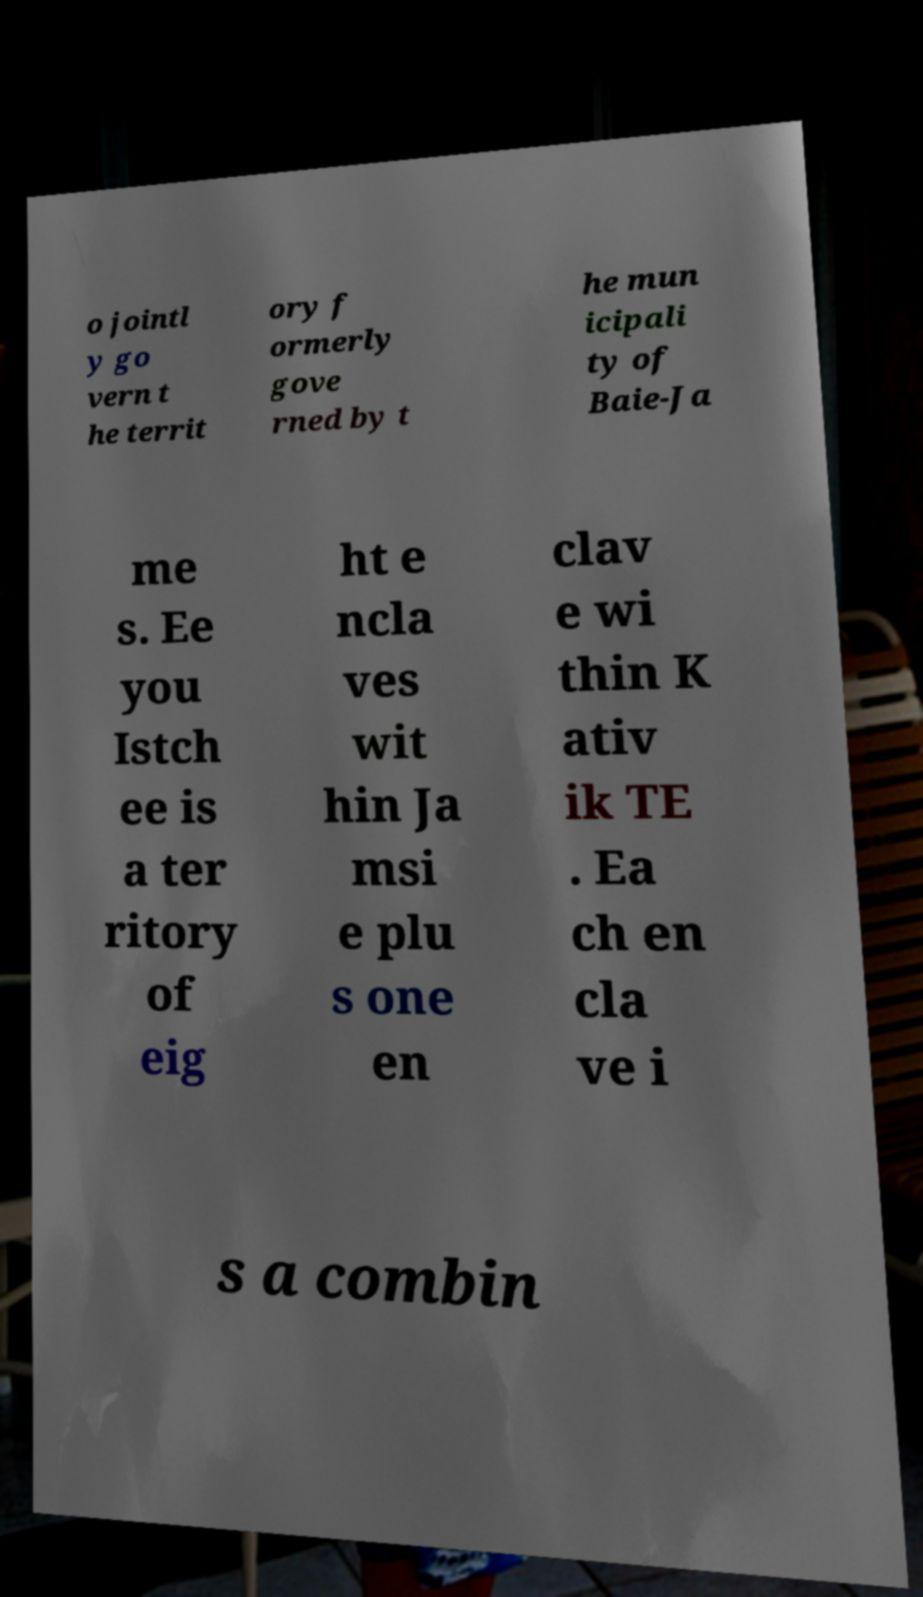Could you extract and type out the text from this image? o jointl y go vern t he territ ory f ormerly gove rned by t he mun icipali ty of Baie-Ja me s. Ee you Istch ee is a ter ritory of eig ht e ncla ves wit hin Ja msi e plu s one en clav e wi thin K ativ ik TE . Ea ch en cla ve i s a combin 